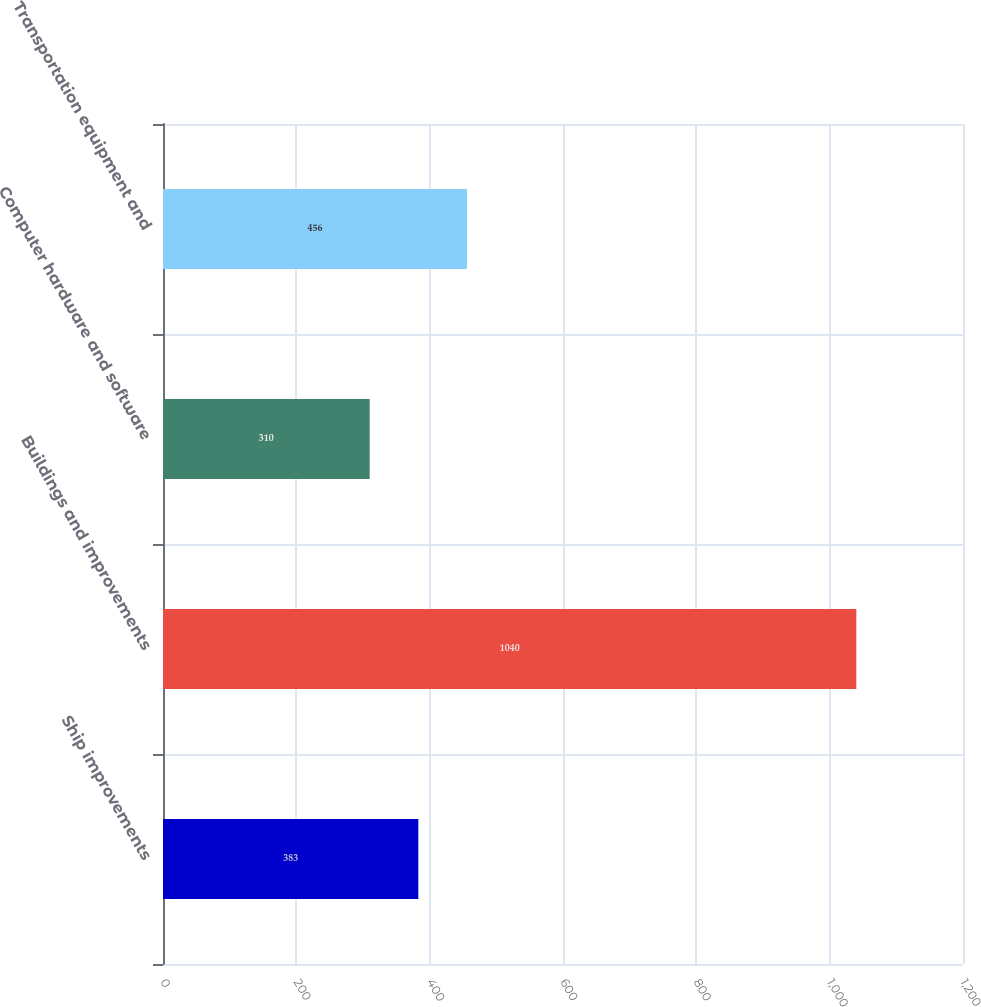Convert chart. <chart><loc_0><loc_0><loc_500><loc_500><bar_chart><fcel>Ship improvements<fcel>Buildings and improvements<fcel>Computer hardware and software<fcel>Transportation equipment and<nl><fcel>383<fcel>1040<fcel>310<fcel>456<nl></chart> 